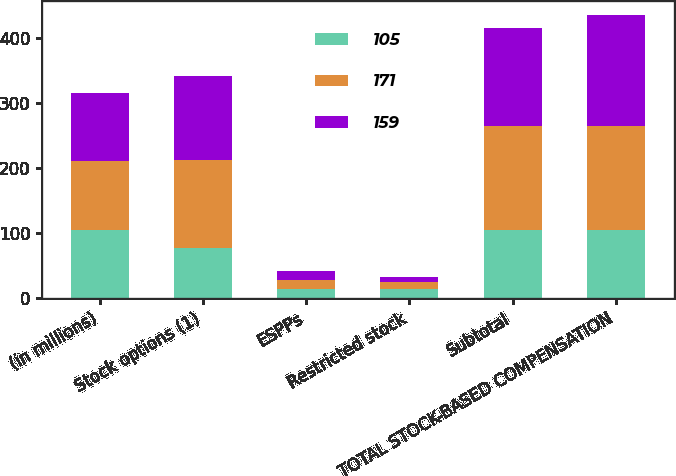Convert chart. <chart><loc_0><loc_0><loc_500><loc_500><stacked_bar_chart><ecel><fcel>(in millions)<fcel>Stock options (1)<fcel>ESPPs<fcel>Restricted stock<fcel>Subtotal<fcel>TOTAL STOCK-BASED COMPENSATION<nl><fcel>105<fcel>105<fcel>77<fcel>14<fcel>14<fcel>105<fcel>105<nl><fcel>171<fcel>105<fcel>135<fcel>14<fcel>10<fcel>159<fcel>159<nl><fcel>159<fcel>105<fcel>129<fcel>14<fcel>8<fcel>151<fcel>171<nl></chart> 